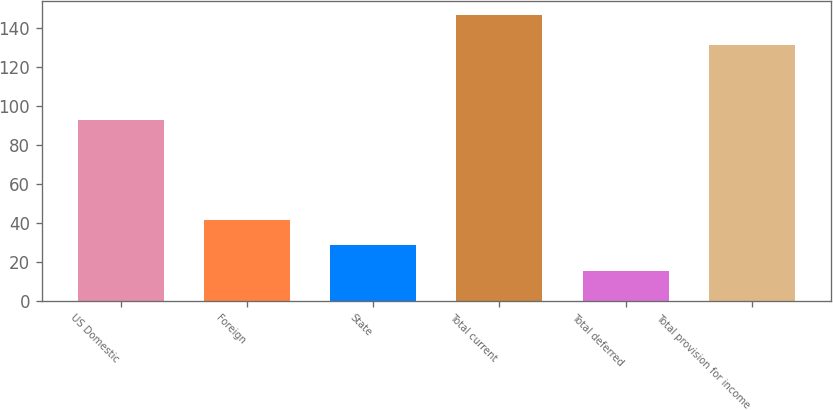<chart> <loc_0><loc_0><loc_500><loc_500><bar_chart><fcel>US Domestic<fcel>Foreign<fcel>State<fcel>Total current<fcel>Total deferred<fcel>Total provision for income<nl><fcel>92.9<fcel>41.66<fcel>28.53<fcel>146.7<fcel>15.4<fcel>131.3<nl></chart> 